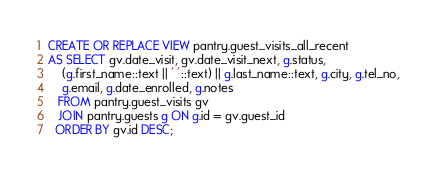Convert code to text. <code><loc_0><loc_0><loc_500><loc_500><_SQL_>CREATE OR REPLACE VIEW pantry.guest_visits_all_recent
AS SELECT gv.date_visit, gv.date_visit_next, g.status, 
    (g.first_name::text || ' '::text) || g.last_name::text, g.city, g.tel_no, 
    g.email, g.date_enrolled, g.notes
   FROM pantry.guest_visits gv
   JOIN pantry.guests g ON g.id = gv.guest_id
  ORDER BY gv.id DESC;
</code> 